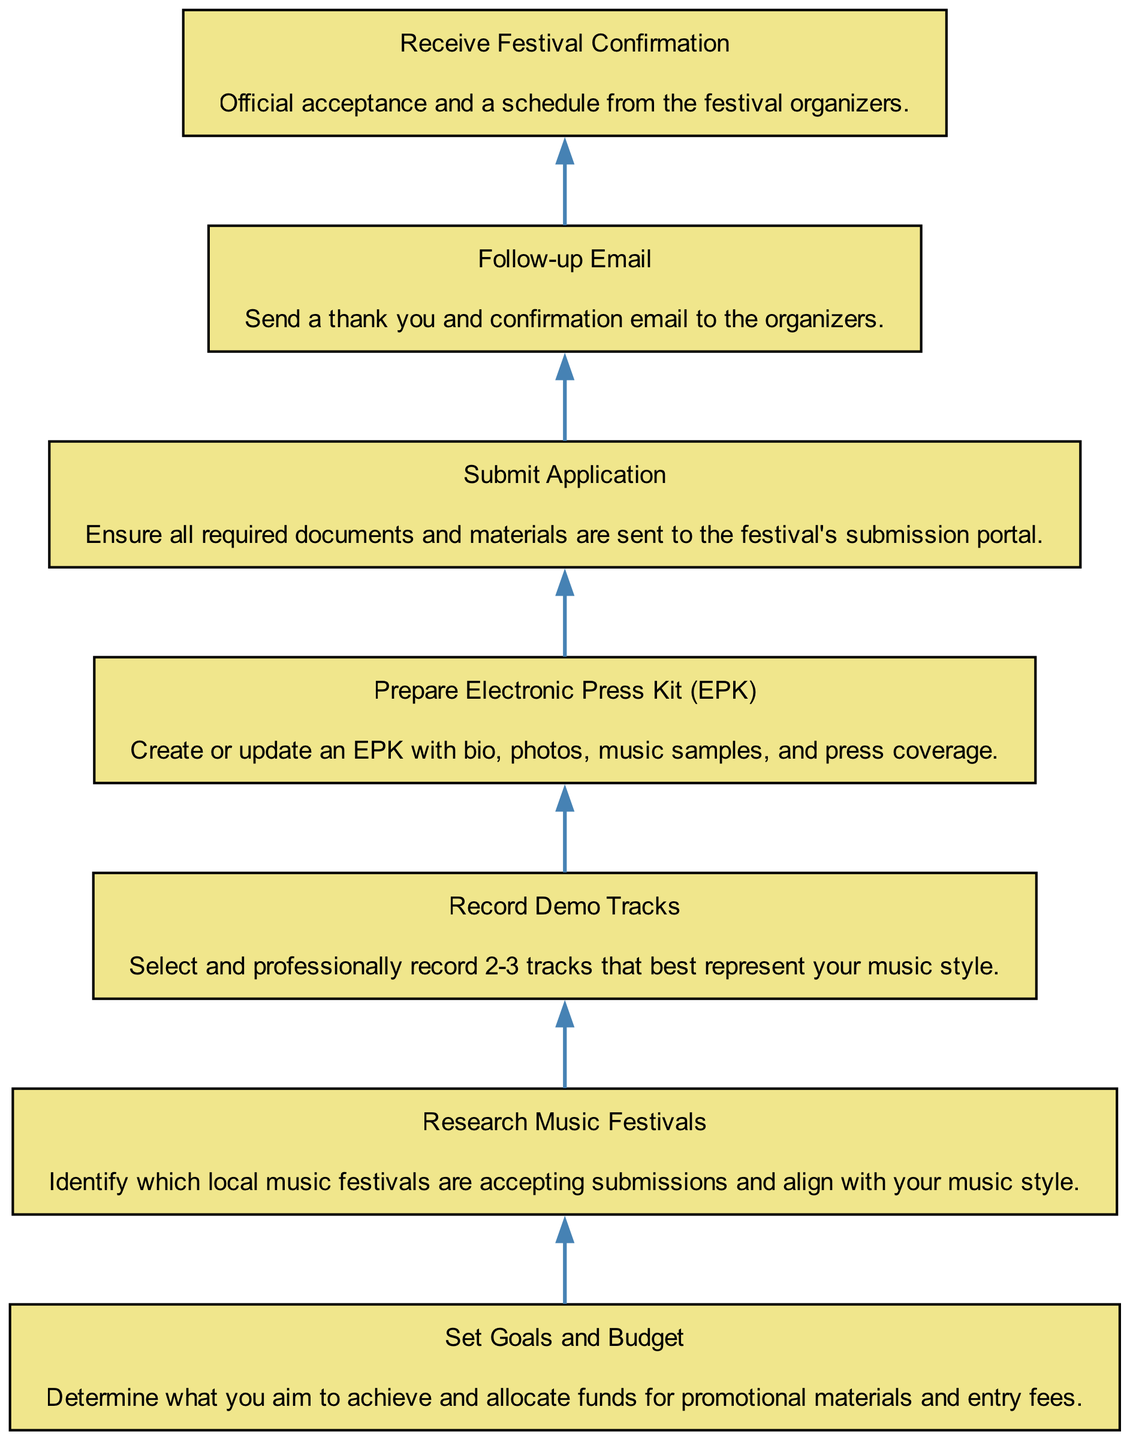What's the first step before receiving festival confirmation? The last step in the flow before receiving festival confirmation is "Submit Application." This indicates that the application must be submitted prior to receiving any confirmation regarding participation in a festival.
Answer: Submit Application How many total steps are included in the process? The diagram lists a total of seven distinct steps that outline the application process for music festivals. Each step leads to the next in a structured manner from the bottom to the top.
Answer: Seven What is required after receiving festival confirmation? After receiving festival confirmation, the next required action is to send a "Follow-up Email." This step is essential to confirm acceptance and express gratitude towards the organizers.
Answer: Follow-up Email Which step involves preparing promotional materials? The step labeled "Prepare Electronic Press Kit (EPK)" specifically focuses on creating or updating promotional materials that showcase the artist. It details the necessary contents for effective self-promotion to the festival organizers.
Answer: Prepare Electronic Press Kit (EPK) What comes before recording demo tracks? Prior to recording demo tracks, the previous step is "Research Music Festivals." This step ensures that the artist finds festivals that align with their music style before creating the content to submit.
Answer: Research Music Festivals How do you determine the music festivals to apply for? You must "Research Music Festivals" to identify which festivals are accepting applications. This should be done before applying, ensuring the selected festivals match your music style.
Answer: Research Music Festivals What is the last action depicted in the diagram? The final action depicted in the flowchart is "Receive Festival Confirmation." This indicates successful completion of the application process and acceptance into the festival, closing the loop on the initial submission efforts.
Answer: Receive Festival Confirmation What is the relationship between 'Set Goals and Budget' and 'Research Music Festivals'? "Set Goals and Budget" occurs before "Research Music Festivals." This means you should have a clear goal and budget in mind before looking for festivals that align with those objectives.
Answer: Sequential What is the main focus of 'Record Demo Tracks'? The main focus of "Record Demo Tracks" is to select and professionally record a few tracks that best represent an artist's music style for submission to festivals. This is essential for presenting oneself authentically.
Answer: Select and professionally record tracks 